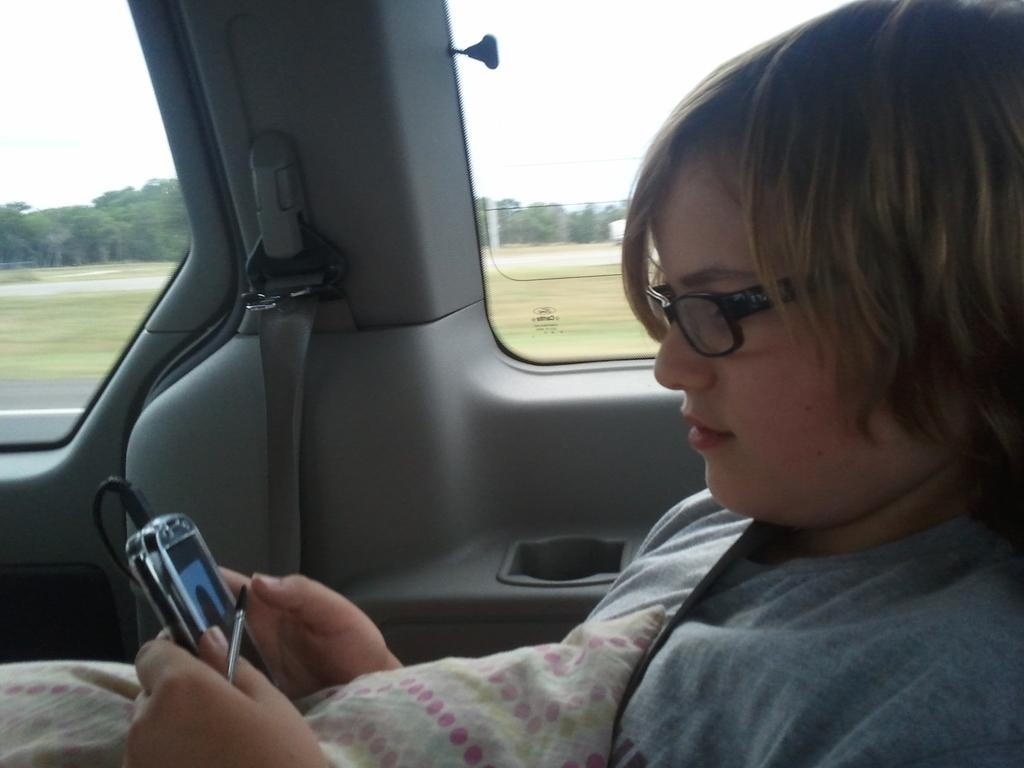What is the girl doing in the car? The girl is sitting in a car and looking at a mobile phone. What can be seen outside the car window? There are trees visible outside the car window. What type of screw can be seen holding the car door in the image? There is no screw visible in the image, and the car door's condition is not mentioned. What day of the week is it in the image? The day of the week cannot be determined from the image. 